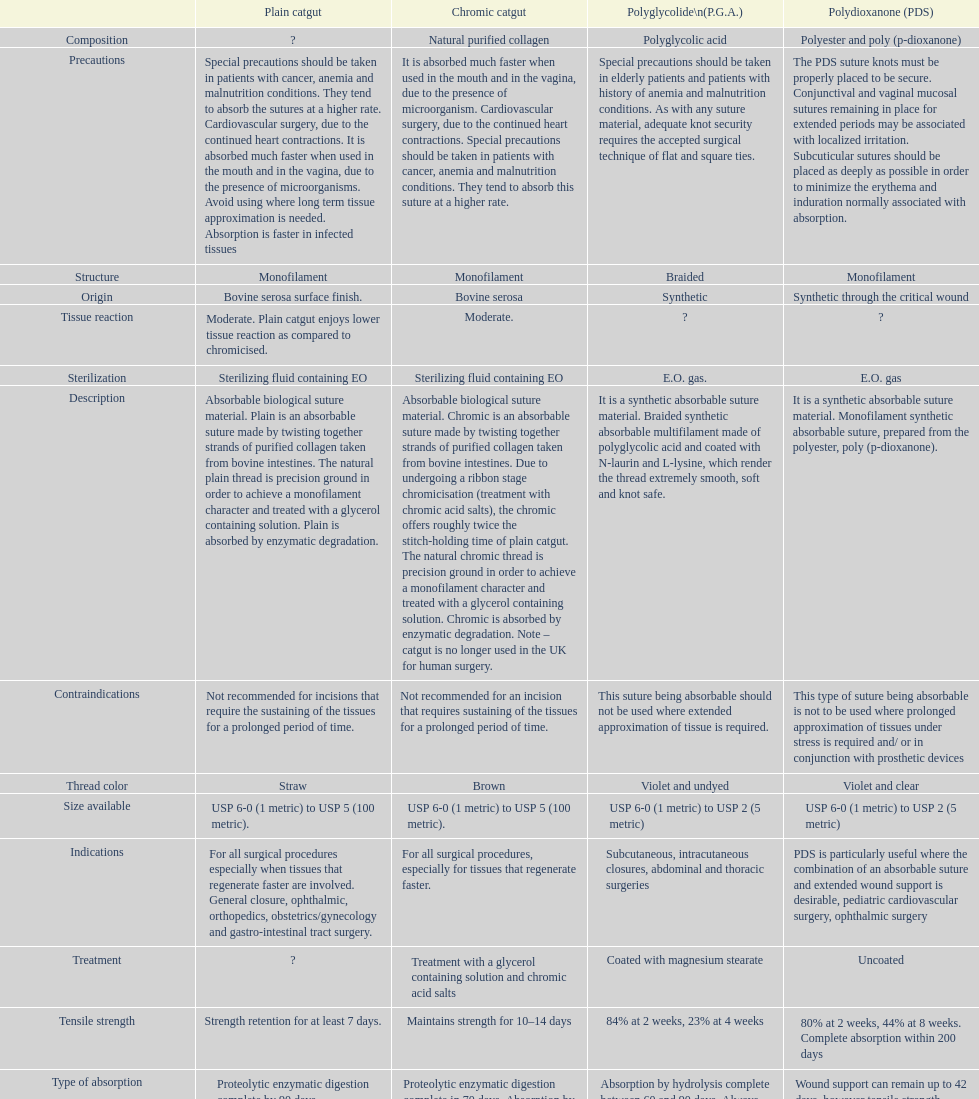What type of suture is not to be used in conjunction with prosthetic devices? Polydioxanone (PDS). 